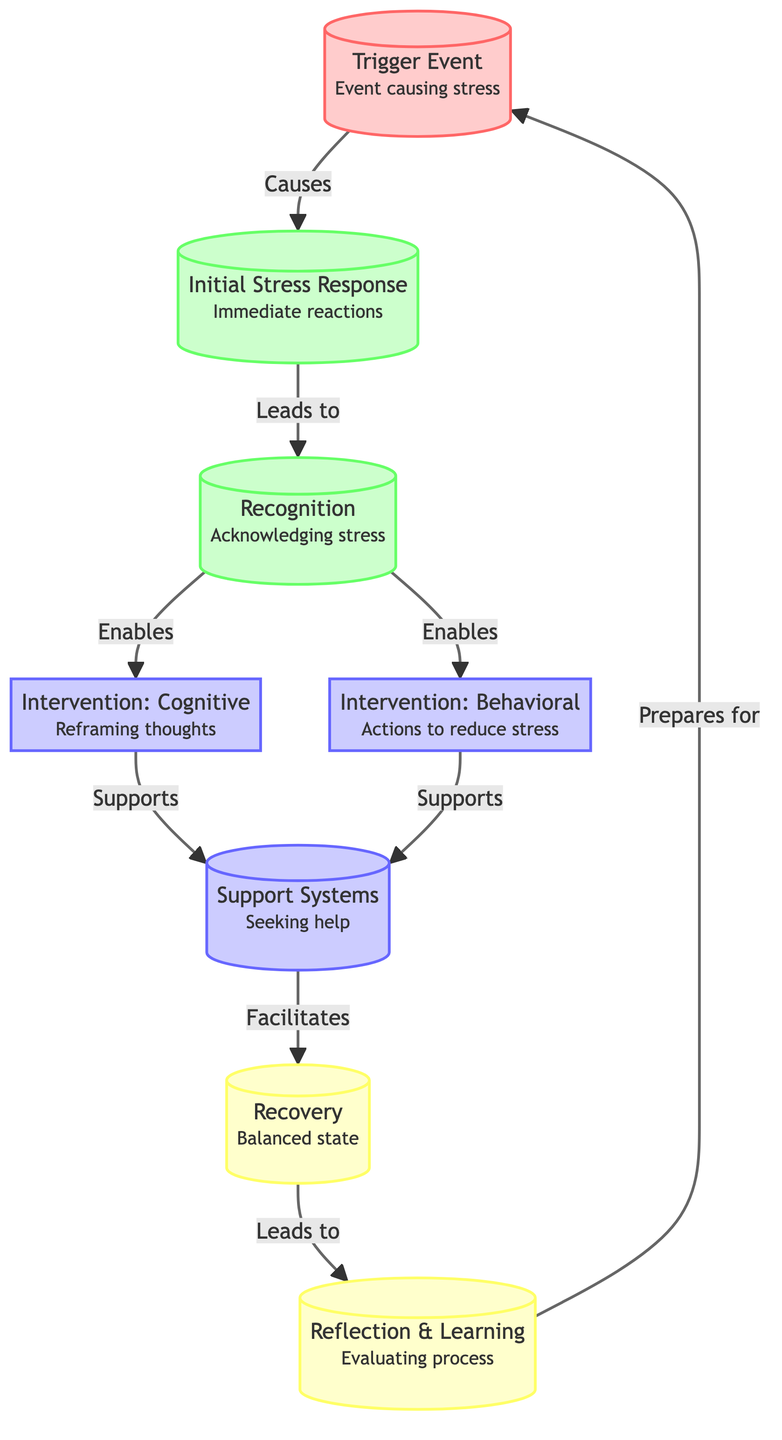What is the first node in the diagram? The first node in the diagram is labeled "Trigger Event," which indicates the event that causes stress.
Answer: Trigger Event How many interventions are listed in the diagram? There are two interventions specified in the diagram: one cognitive and one behavioral.
Answer: 2 What is the last step of the recovery process? The last step in the recovery process is "Reflection & Learning," which involves evaluating the process of stress response and recovery.
Answer: Reflection & Learning Which node follows the "Recognition" node? The node that follows "Recognition" in the diagram is "Intervention: Cognitive," which focuses on reframing thoughts.
Answer: Intervention: Cognitive Which nodes support the "Support Systems" step? Both "Intervention: Cognitive" and "Intervention: Behavioral" lead to and support the "Support Systems" node.
Answer: Intervention: Cognitive and Intervention: Behavioral What color represents the intervention nodes in the diagram? The intervention nodes are represented in a light purple color, as indicated by the class definition for intervention nodes.
Answer: Light purple How does the initial stress response relate to the recovery phase? The "Initial Stress Response" leads to "Recognition," which is a crucial step that eventually facilitates recovery through support systems, in a cyclical manner.
Answer: Leads to Recognition Which part of the diagram emphasizes seeking help? The part of the diagram that emphasizes seeking help is under the "Support Systems" node, which represents a collaboration of the interventions.
Answer: Support Systems 